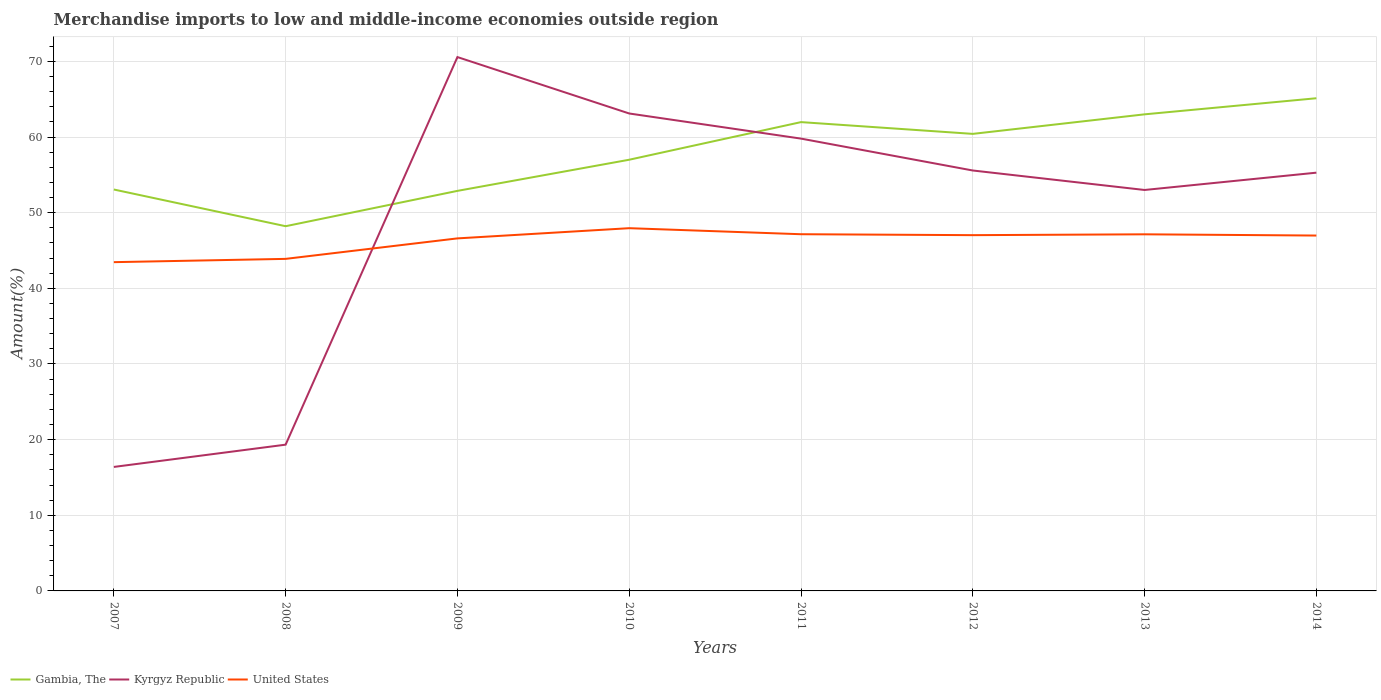How many different coloured lines are there?
Provide a succinct answer. 3. Across all years, what is the maximum percentage of amount earned from merchandise imports in Gambia, The?
Give a very brief answer. 48.21. In which year was the percentage of amount earned from merchandise imports in Gambia, The maximum?
Give a very brief answer. 2008. What is the total percentage of amount earned from merchandise imports in United States in the graph?
Give a very brief answer. -4.49. What is the difference between the highest and the second highest percentage of amount earned from merchandise imports in Gambia, The?
Your answer should be compact. 16.92. What is the difference between the highest and the lowest percentage of amount earned from merchandise imports in Kyrgyz Republic?
Offer a terse response. 6. How many years are there in the graph?
Offer a very short reply. 8. Are the values on the major ticks of Y-axis written in scientific E-notation?
Keep it short and to the point. No. Does the graph contain grids?
Provide a succinct answer. Yes. Where does the legend appear in the graph?
Offer a very short reply. Bottom left. How many legend labels are there?
Ensure brevity in your answer.  3. How are the legend labels stacked?
Provide a short and direct response. Horizontal. What is the title of the graph?
Ensure brevity in your answer.  Merchandise imports to low and middle-income economies outside region. Does "Trinidad and Tobago" appear as one of the legend labels in the graph?
Your answer should be very brief. No. What is the label or title of the Y-axis?
Provide a short and direct response. Amount(%). What is the Amount(%) in Gambia, The in 2007?
Provide a succinct answer. 53.06. What is the Amount(%) in Kyrgyz Republic in 2007?
Your response must be concise. 16.39. What is the Amount(%) of United States in 2007?
Offer a very short reply. 43.46. What is the Amount(%) in Gambia, The in 2008?
Your answer should be very brief. 48.21. What is the Amount(%) in Kyrgyz Republic in 2008?
Ensure brevity in your answer.  19.33. What is the Amount(%) of United States in 2008?
Ensure brevity in your answer.  43.89. What is the Amount(%) in Gambia, The in 2009?
Your answer should be very brief. 52.88. What is the Amount(%) of Kyrgyz Republic in 2009?
Provide a short and direct response. 70.57. What is the Amount(%) in United States in 2009?
Your answer should be compact. 46.6. What is the Amount(%) in Gambia, The in 2010?
Provide a short and direct response. 57. What is the Amount(%) in Kyrgyz Republic in 2010?
Give a very brief answer. 63.11. What is the Amount(%) in United States in 2010?
Make the answer very short. 47.95. What is the Amount(%) of Gambia, The in 2011?
Provide a succinct answer. 61.97. What is the Amount(%) in Kyrgyz Republic in 2011?
Give a very brief answer. 59.79. What is the Amount(%) in United States in 2011?
Ensure brevity in your answer.  47.15. What is the Amount(%) of Gambia, The in 2012?
Your response must be concise. 60.42. What is the Amount(%) in Kyrgyz Republic in 2012?
Keep it short and to the point. 55.58. What is the Amount(%) in United States in 2012?
Your response must be concise. 47.03. What is the Amount(%) of Gambia, The in 2013?
Provide a succinct answer. 63. What is the Amount(%) in Kyrgyz Republic in 2013?
Make the answer very short. 53. What is the Amount(%) in United States in 2013?
Give a very brief answer. 47.14. What is the Amount(%) of Gambia, The in 2014?
Make the answer very short. 65.13. What is the Amount(%) in Kyrgyz Republic in 2014?
Keep it short and to the point. 55.29. What is the Amount(%) in United States in 2014?
Your response must be concise. 46.98. Across all years, what is the maximum Amount(%) of Gambia, The?
Offer a terse response. 65.13. Across all years, what is the maximum Amount(%) of Kyrgyz Republic?
Give a very brief answer. 70.57. Across all years, what is the maximum Amount(%) in United States?
Offer a very short reply. 47.95. Across all years, what is the minimum Amount(%) in Gambia, The?
Offer a very short reply. 48.21. Across all years, what is the minimum Amount(%) in Kyrgyz Republic?
Keep it short and to the point. 16.39. Across all years, what is the minimum Amount(%) of United States?
Keep it short and to the point. 43.46. What is the total Amount(%) of Gambia, The in the graph?
Your response must be concise. 461.68. What is the total Amount(%) in Kyrgyz Republic in the graph?
Your answer should be compact. 393.07. What is the total Amount(%) in United States in the graph?
Your response must be concise. 370.21. What is the difference between the Amount(%) in Gambia, The in 2007 and that in 2008?
Your answer should be compact. 4.85. What is the difference between the Amount(%) of Kyrgyz Republic in 2007 and that in 2008?
Provide a succinct answer. -2.94. What is the difference between the Amount(%) of United States in 2007 and that in 2008?
Offer a very short reply. -0.43. What is the difference between the Amount(%) of Gambia, The in 2007 and that in 2009?
Give a very brief answer. 0.18. What is the difference between the Amount(%) in Kyrgyz Republic in 2007 and that in 2009?
Your response must be concise. -54.18. What is the difference between the Amount(%) in United States in 2007 and that in 2009?
Ensure brevity in your answer.  -3.14. What is the difference between the Amount(%) in Gambia, The in 2007 and that in 2010?
Your answer should be very brief. -3.94. What is the difference between the Amount(%) of Kyrgyz Republic in 2007 and that in 2010?
Provide a succinct answer. -46.72. What is the difference between the Amount(%) of United States in 2007 and that in 2010?
Offer a very short reply. -4.49. What is the difference between the Amount(%) in Gambia, The in 2007 and that in 2011?
Provide a short and direct response. -8.91. What is the difference between the Amount(%) of Kyrgyz Republic in 2007 and that in 2011?
Provide a short and direct response. -43.4. What is the difference between the Amount(%) of United States in 2007 and that in 2011?
Give a very brief answer. -3.69. What is the difference between the Amount(%) of Gambia, The in 2007 and that in 2012?
Make the answer very short. -7.35. What is the difference between the Amount(%) of Kyrgyz Republic in 2007 and that in 2012?
Provide a succinct answer. -39.19. What is the difference between the Amount(%) of United States in 2007 and that in 2012?
Your answer should be very brief. -3.57. What is the difference between the Amount(%) in Gambia, The in 2007 and that in 2013?
Your answer should be compact. -9.94. What is the difference between the Amount(%) in Kyrgyz Republic in 2007 and that in 2013?
Keep it short and to the point. -36.61. What is the difference between the Amount(%) of United States in 2007 and that in 2013?
Provide a succinct answer. -3.68. What is the difference between the Amount(%) of Gambia, The in 2007 and that in 2014?
Provide a short and direct response. -12.06. What is the difference between the Amount(%) in Kyrgyz Republic in 2007 and that in 2014?
Make the answer very short. -38.9. What is the difference between the Amount(%) in United States in 2007 and that in 2014?
Ensure brevity in your answer.  -3.52. What is the difference between the Amount(%) of Gambia, The in 2008 and that in 2009?
Provide a succinct answer. -4.67. What is the difference between the Amount(%) in Kyrgyz Republic in 2008 and that in 2009?
Make the answer very short. -51.24. What is the difference between the Amount(%) in United States in 2008 and that in 2009?
Your response must be concise. -2.71. What is the difference between the Amount(%) in Gambia, The in 2008 and that in 2010?
Give a very brief answer. -8.79. What is the difference between the Amount(%) in Kyrgyz Republic in 2008 and that in 2010?
Make the answer very short. -43.78. What is the difference between the Amount(%) in United States in 2008 and that in 2010?
Provide a succinct answer. -4.06. What is the difference between the Amount(%) in Gambia, The in 2008 and that in 2011?
Offer a terse response. -13.76. What is the difference between the Amount(%) in Kyrgyz Republic in 2008 and that in 2011?
Keep it short and to the point. -40.46. What is the difference between the Amount(%) in United States in 2008 and that in 2011?
Provide a succinct answer. -3.26. What is the difference between the Amount(%) of Gambia, The in 2008 and that in 2012?
Your response must be concise. -12.21. What is the difference between the Amount(%) of Kyrgyz Republic in 2008 and that in 2012?
Your answer should be compact. -36.24. What is the difference between the Amount(%) in United States in 2008 and that in 2012?
Give a very brief answer. -3.14. What is the difference between the Amount(%) in Gambia, The in 2008 and that in 2013?
Keep it short and to the point. -14.79. What is the difference between the Amount(%) of Kyrgyz Republic in 2008 and that in 2013?
Ensure brevity in your answer.  -33.67. What is the difference between the Amount(%) of United States in 2008 and that in 2013?
Your response must be concise. -3.25. What is the difference between the Amount(%) of Gambia, The in 2008 and that in 2014?
Make the answer very short. -16.92. What is the difference between the Amount(%) in Kyrgyz Republic in 2008 and that in 2014?
Give a very brief answer. -35.95. What is the difference between the Amount(%) in United States in 2008 and that in 2014?
Your response must be concise. -3.08. What is the difference between the Amount(%) of Gambia, The in 2009 and that in 2010?
Your answer should be very brief. -4.12. What is the difference between the Amount(%) of Kyrgyz Republic in 2009 and that in 2010?
Your response must be concise. 7.46. What is the difference between the Amount(%) of United States in 2009 and that in 2010?
Your response must be concise. -1.35. What is the difference between the Amount(%) of Gambia, The in 2009 and that in 2011?
Make the answer very short. -9.09. What is the difference between the Amount(%) in Kyrgyz Republic in 2009 and that in 2011?
Your answer should be compact. 10.78. What is the difference between the Amount(%) of United States in 2009 and that in 2011?
Ensure brevity in your answer.  -0.55. What is the difference between the Amount(%) in Gambia, The in 2009 and that in 2012?
Keep it short and to the point. -7.54. What is the difference between the Amount(%) in Kyrgyz Republic in 2009 and that in 2012?
Your answer should be very brief. 14.99. What is the difference between the Amount(%) of United States in 2009 and that in 2012?
Your answer should be very brief. -0.43. What is the difference between the Amount(%) of Gambia, The in 2009 and that in 2013?
Your answer should be compact. -10.12. What is the difference between the Amount(%) of Kyrgyz Republic in 2009 and that in 2013?
Give a very brief answer. 17.57. What is the difference between the Amount(%) of United States in 2009 and that in 2013?
Provide a short and direct response. -0.54. What is the difference between the Amount(%) of Gambia, The in 2009 and that in 2014?
Provide a short and direct response. -12.25. What is the difference between the Amount(%) of Kyrgyz Republic in 2009 and that in 2014?
Your answer should be compact. 15.28. What is the difference between the Amount(%) of United States in 2009 and that in 2014?
Provide a short and direct response. -0.38. What is the difference between the Amount(%) in Gambia, The in 2010 and that in 2011?
Offer a terse response. -4.97. What is the difference between the Amount(%) in Kyrgyz Republic in 2010 and that in 2011?
Provide a short and direct response. 3.32. What is the difference between the Amount(%) in United States in 2010 and that in 2011?
Provide a short and direct response. 0.8. What is the difference between the Amount(%) of Gambia, The in 2010 and that in 2012?
Make the answer very short. -3.42. What is the difference between the Amount(%) in Kyrgyz Republic in 2010 and that in 2012?
Offer a terse response. 7.54. What is the difference between the Amount(%) in United States in 2010 and that in 2012?
Make the answer very short. 0.92. What is the difference between the Amount(%) of Gambia, The in 2010 and that in 2013?
Ensure brevity in your answer.  -6. What is the difference between the Amount(%) in Kyrgyz Republic in 2010 and that in 2013?
Offer a very short reply. 10.11. What is the difference between the Amount(%) of United States in 2010 and that in 2013?
Your response must be concise. 0.81. What is the difference between the Amount(%) of Gambia, The in 2010 and that in 2014?
Offer a terse response. -8.13. What is the difference between the Amount(%) in Kyrgyz Republic in 2010 and that in 2014?
Make the answer very short. 7.82. What is the difference between the Amount(%) of United States in 2010 and that in 2014?
Make the answer very short. 0.97. What is the difference between the Amount(%) in Gambia, The in 2011 and that in 2012?
Provide a succinct answer. 1.55. What is the difference between the Amount(%) in Kyrgyz Republic in 2011 and that in 2012?
Make the answer very short. 4.21. What is the difference between the Amount(%) of United States in 2011 and that in 2012?
Give a very brief answer. 0.12. What is the difference between the Amount(%) in Gambia, The in 2011 and that in 2013?
Offer a terse response. -1.03. What is the difference between the Amount(%) of Kyrgyz Republic in 2011 and that in 2013?
Your answer should be very brief. 6.79. What is the difference between the Amount(%) in United States in 2011 and that in 2013?
Provide a short and direct response. 0.01. What is the difference between the Amount(%) of Gambia, The in 2011 and that in 2014?
Your answer should be compact. -3.16. What is the difference between the Amount(%) of Kyrgyz Republic in 2011 and that in 2014?
Provide a succinct answer. 4.5. What is the difference between the Amount(%) in United States in 2011 and that in 2014?
Keep it short and to the point. 0.17. What is the difference between the Amount(%) in Gambia, The in 2012 and that in 2013?
Provide a succinct answer. -2.58. What is the difference between the Amount(%) of Kyrgyz Republic in 2012 and that in 2013?
Offer a terse response. 2.58. What is the difference between the Amount(%) of United States in 2012 and that in 2013?
Provide a succinct answer. -0.11. What is the difference between the Amount(%) in Gambia, The in 2012 and that in 2014?
Provide a succinct answer. -4.71. What is the difference between the Amount(%) in Kyrgyz Republic in 2012 and that in 2014?
Make the answer very short. 0.29. What is the difference between the Amount(%) of United States in 2012 and that in 2014?
Make the answer very short. 0.05. What is the difference between the Amount(%) in Gambia, The in 2013 and that in 2014?
Provide a short and direct response. -2.13. What is the difference between the Amount(%) of Kyrgyz Republic in 2013 and that in 2014?
Your answer should be very brief. -2.29. What is the difference between the Amount(%) in United States in 2013 and that in 2014?
Offer a very short reply. 0.16. What is the difference between the Amount(%) of Gambia, The in 2007 and the Amount(%) of Kyrgyz Republic in 2008?
Provide a short and direct response. 33.73. What is the difference between the Amount(%) of Gambia, The in 2007 and the Amount(%) of United States in 2008?
Give a very brief answer. 9.17. What is the difference between the Amount(%) in Kyrgyz Republic in 2007 and the Amount(%) in United States in 2008?
Offer a terse response. -27.5. What is the difference between the Amount(%) of Gambia, The in 2007 and the Amount(%) of Kyrgyz Republic in 2009?
Give a very brief answer. -17.51. What is the difference between the Amount(%) in Gambia, The in 2007 and the Amount(%) in United States in 2009?
Your answer should be compact. 6.46. What is the difference between the Amount(%) of Kyrgyz Republic in 2007 and the Amount(%) of United States in 2009?
Your answer should be very brief. -30.21. What is the difference between the Amount(%) in Gambia, The in 2007 and the Amount(%) in Kyrgyz Republic in 2010?
Offer a terse response. -10.05. What is the difference between the Amount(%) in Gambia, The in 2007 and the Amount(%) in United States in 2010?
Provide a short and direct response. 5.11. What is the difference between the Amount(%) of Kyrgyz Republic in 2007 and the Amount(%) of United States in 2010?
Give a very brief answer. -31.56. What is the difference between the Amount(%) of Gambia, The in 2007 and the Amount(%) of Kyrgyz Republic in 2011?
Ensure brevity in your answer.  -6.73. What is the difference between the Amount(%) in Gambia, The in 2007 and the Amount(%) in United States in 2011?
Give a very brief answer. 5.91. What is the difference between the Amount(%) of Kyrgyz Republic in 2007 and the Amount(%) of United States in 2011?
Keep it short and to the point. -30.76. What is the difference between the Amount(%) in Gambia, The in 2007 and the Amount(%) in Kyrgyz Republic in 2012?
Your response must be concise. -2.51. What is the difference between the Amount(%) of Gambia, The in 2007 and the Amount(%) of United States in 2012?
Offer a very short reply. 6.03. What is the difference between the Amount(%) of Kyrgyz Republic in 2007 and the Amount(%) of United States in 2012?
Provide a succinct answer. -30.64. What is the difference between the Amount(%) of Gambia, The in 2007 and the Amount(%) of Kyrgyz Republic in 2013?
Provide a succinct answer. 0.06. What is the difference between the Amount(%) of Gambia, The in 2007 and the Amount(%) of United States in 2013?
Your answer should be compact. 5.92. What is the difference between the Amount(%) in Kyrgyz Republic in 2007 and the Amount(%) in United States in 2013?
Offer a very short reply. -30.75. What is the difference between the Amount(%) in Gambia, The in 2007 and the Amount(%) in Kyrgyz Republic in 2014?
Your answer should be very brief. -2.22. What is the difference between the Amount(%) of Gambia, The in 2007 and the Amount(%) of United States in 2014?
Offer a very short reply. 6.09. What is the difference between the Amount(%) in Kyrgyz Republic in 2007 and the Amount(%) in United States in 2014?
Ensure brevity in your answer.  -30.59. What is the difference between the Amount(%) in Gambia, The in 2008 and the Amount(%) in Kyrgyz Republic in 2009?
Your answer should be compact. -22.36. What is the difference between the Amount(%) in Gambia, The in 2008 and the Amount(%) in United States in 2009?
Provide a short and direct response. 1.61. What is the difference between the Amount(%) in Kyrgyz Republic in 2008 and the Amount(%) in United States in 2009?
Your answer should be compact. -27.27. What is the difference between the Amount(%) of Gambia, The in 2008 and the Amount(%) of Kyrgyz Republic in 2010?
Provide a succinct answer. -14.9. What is the difference between the Amount(%) in Gambia, The in 2008 and the Amount(%) in United States in 2010?
Make the answer very short. 0.26. What is the difference between the Amount(%) in Kyrgyz Republic in 2008 and the Amount(%) in United States in 2010?
Your answer should be compact. -28.62. What is the difference between the Amount(%) in Gambia, The in 2008 and the Amount(%) in Kyrgyz Republic in 2011?
Give a very brief answer. -11.58. What is the difference between the Amount(%) of Gambia, The in 2008 and the Amount(%) of United States in 2011?
Your answer should be compact. 1.06. What is the difference between the Amount(%) of Kyrgyz Republic in 2008 and the Amount(%) of United States in 2011?
Offer a very short reply. -27.82. What is the difference between the Amount(%) of Gambia, The in 2008 and the Amount(%) of Kyrgyz Republic in 2012?
Your answer should be compact. -7.37. What is the difference between the Amount(%) of Gambia, The in 2008 and the Amount(%) of United States in 2012?
Your response must be concise. 1.18. What is the difference between the Amount(%) of Kyrgyz Republic in 2008 and the Amount(%) of United States in 2012?
Offer a very short reply. -27.7. What is the difference between the Amount(%) in Gambia, The in 2008 and the Amount(%) in Kyrgyz Republic in 2013?
Your answer should be very brief. -4.79. What is the difference between the Amount(%) of Gambia, The in 2008 and the Amount(%) of United States in 2013?
Give a very brief answer. 1.07. What is the difference between the Amount(%) of Kyrgyz Republic in 2008 and the Amount(%) of United States in 2013?
Provide a short and direct response. -27.81. What is the difference between the Amount(%) of Gambia, The in 2008 and the Amount(%) of Kyrgyz Republic in 2014?
Your response must be concise. -7.08. What is the difference between the Amount(%) in Gambia, The in 2008 and the Amount(%) in United States in 2014?
Your answer should be very brief. 1.23. What is the difference between the Amount(%) in Kyrgyz Republic in 2008 and the Amount(%) in United States in 2014?
Your response must be concise. -27.64. What is the difference between the Amount(%) in Gambia, The in 2009 and the Amount(%) in Kyrgyz Republic in 2010?
Provide a short and direct response. -10.23. What is the difference between the Amount(%) of Gambia, The in 2009 and the Amount(%) of United States in 2010?
Provide a succinct answer. 4.93. What is the difference between the Amount(%) in Kyrgyz Republic in 2009 and the Amount(%) in United States in 2010?
Your answer should be very brief. 22.62. What is the difference between the Amount(%) in Gambia, The in 2009 and the Amount(%) in Kyrgyz Republic in 2011?
Give a very brief answer. -6.91. What is the difference between the Amount(%) of Gambia, The in 2009 and the Amount(%) of United States in 2011?
Your answer should be compact. 5.73. What is the difference between the Amount(%) in Kyrgyz Republic in 2009 and the Amount(%) in United States in 2011?
Keep it short and to the point. 23.42. What is the difference between the Amount(%) in Gambia, The in 2009 and the Amount(%) in Kyrgyz Republic in 2012?
Keep it short and to the point. -2.69. What is the difference between the Amount(%) in Gambia, The in 2009 and the Amount(%) in United States in 2012?
Make the answer very short. 5.85. What is the difference between the Amount(%) of Kyrgyz Republic in 2009 and the Amount(%) of United States in 2012?
Keep it short and to the point. 23.54. What is the difference between the Amount(%) of Gambia, The in 2009 and the Amount(%) of Kyrgyz Republic in 2013?
Keep it short and to the point. -0.12. What is the difference between the Amount(%) in Gambia, The in 2009 and the Amount(%) in United States in 2013?
Offer a very short reply. 5.74. What is the difference between the Amount(%) of Kyrgyz Republic in 2009 and the Amount(%) of United States in 2013?
Give a very brief answer. 23.43. What is the difference between the Amount(%) in Gambia, The in 2009 and the Amount(%) in Kyrgyz Republic in 2014?
Provide a short and direct response. -2.41. What is the difference between the Amount(%) of Gambia, The in 2009 and the Amount(%) of United States in 2014?
Offer a very short reply. 5.9. What is the difference between the Amount(%) in Kyrgyz Republic in 2009 and the Amount(%) in United States in 2014?
Your answer should be very brief. 23.59. What is the difference between the Amount(%) of Gambia, The in 2010 and the Amount(%) of Kyrgyz Republic in 2011?
Your response must be concise. -2.79. What is the difference between the Amount(%) in Gambia, The in 2010 and the Amount(%) in United States in 2011?
Give a very brief answer. 9.85. What is the difference between the Amount(%) in Kyrgyz Republic in 2010 and the Amount(%) in United States in 2011?
Offer a terse response. 15.96. What is the difference between the Amount(%) of Gambia, The in 2010 and the Amount(%) of Kyrgyz Republic in 2012?
Offer a terse response. 1.42. What is the difference between the Amount(%) in Gambia, The in 2010 and the Amount(%) in United States in 2012?
Your answer should be compact. 9.97. What is the difference between the Amount(%) in Kyrgyz Republic in 2010 and the Amount(%) in United States in 2012?
Offer a very short reply. 16.08. What is the difference between the Amount(%) of Gambia, The in 2010 and the Amount(%) of Kyrgyz Republic in 2013?
Provide a succinct answer. 4. What is the difference between the Amount(%) in Gambia, The in 2010 and the Amount(%) in United States in 2013?
Offer a terse response. 9.86. What is the difference between the Amount(%) in Kyrgyz Republic in 2010 and the Amount(%) in United States in 2013?
Your answer should be compact. 15.97. What is the difference between the Amount(%) in Gambia, The in 2010 and the Amount(%) in Kyrgyz Republic in 2014?
Your response must be concise. 1.71. What is the difference between the Amount(%) of Gambia, The in 2010 and the Amount(%) of United States in 2014?
Provide a succinct answer. 10.02. What is the difference between the Amount(%) in Kyrgyz Republic in 2010 and the Amount(%) in United States in 2014?
Provide a succinct answer. 16.13. What is the difference between the Amount(%) of Gambia, The in 2011 and the Amount(%) of Kyrgyz Republic in 2012?
Offer a very short reply. 6.4. What is the difference between the Amount(%) in Gambia, The in 2011 and the Amount(%) in United States in 2012?
Give a very brief answer. 14.94. What is the difference between the Amount(%) in Kyrgyz Republic in 2011 and the Amount(%) in United States in 2012?
Offer a very short reply. 12.76. What is the difference between the Amount(%) of Gambia, The in 2011 and the Amount(%) of Kyrgyz Republic in 2013?
Give a very brief answer. 8.97. What is the difference between the Amount(%) in Gambia, The in 2011 and the Amount(%) in United States in 2013?
Provide a short and direct response. 14.83. What is the difference between the Amount(%) in Kyrgyz Republic in 2011 and the Amount(%) in United States in 2013?
Provide a short and direct response. 12.65. What is the difference between the Amount(%) in Gambia, The in 2011 and the Amount(%) in Kyrgyz Republic in 2014?
Your answer should be very brief. 6.68. What is the difference between the Amount(%) in Gambia, The in 2011 and the Amount(%) in United States in 2014?
Make the answer very short. 14.99. What is the difference between the Amount(%) of Kyrgyz Republic in 2011 and the Amount(%) of United States in 2014?
Ensure brevity in your answer.  12.81. What is the difference between the Amount(%) in Gambia, The in 2012 and the Amount(%) in Kyrgyz Republic in 2013?
Keep it short and to the point. 7.42. What is the difference between the Amount(%) in Gambia, The in 2012 and the Amount(%) in United States in 2013?
Offer a very short reply. 13.28. What is the difference between the Amount(%) of Kyrgyz Republic in 2012 and the Amount(%) of United States in 2013?
Your answer should be compact. 8.44. What is the difference between the Amount(%) of Gambia, The in 2012 and the Amount(%) of Kyrgyz Republic in 2014?
Ensure brevity in your answer.  5.13. What is the difference between the Amount(%) in Gambia, The in 2012 and the Amount(%) in United States in 2014?
Your answer should be compact. 13.44. What is the difference between the Amount(%) of Kyrgyz Republic in 2012 and the Amount(%) of United States in 2014?
Keep it short and to the point. 8.6. What is the difference between the Amount(%) of Gambia, The in 2013 and the Amount(%) of Kyrgyz Republic in 2014?
Ensure brevity in your answer.  7.71. What is the difference between the Amount(%) of Gambia, The in 2013 and the Amount(%) of United States in 2014?
Offer a very short reply. 16.02. What is the difference between the Amount(%) of Kyrgyz Republic in 2013 and the Amount(%) of United States in 2014?
Provide a succinct answer. 6.02. What is the average Amount(%) in Gambia, The per year?
Provide a short and direct response. 57.71. What is the average Amount(%) in Kyrgyz Republic per year?
Offer a terse response. 49.13. What is the average Amount(%) in United States per year?
Provide a succinct answer. 46.28. In the year 2007, what is the difference between the Amount(%) in Gambia, The and Amount(%) in Kyrgyz Republic?
Ensure brevity in your answer.  36.67. In the year 2007, what is the difference between the Amount(%) in Gambia, The and Amount(%) in United States?
Your answer should be very brief. 9.6. In the year 2007, what is the difference between the Amount(%) of Kyrgyz Republic and Amount(%) of United States?
Provide a succinct answer. -27.07. In the year 2008, what is the difference between the Amount(%) in Gambia, The and Amount(%) in Kyrgyz Republic?
Make the answer very short. 28.88. In the year 2008, what is the difference between the Amount(%) of Gambia, The and Amount(%) of United States?
Your response must be concise. 4.32. In the year 2008, what is the difference between the Amount(%) of Kyrgyz Republic and Amount(%) of United States?
Keep it short and to the point. -24.56. In the year 2009, what is the difference between the Amount(%) of Gambia, The and Amount(%) of Kyrgyz Republic?
Your answer should be compact. -17.69. In the year 2009, what is the difference between the Amount(%) in Gambia, The and Amount(%) in United States?
Offer a terse response. 6.28. In the year 2009, what is the difference between the Amount(%) of Kyrgyz Republic and Amount(%) of United States?
Your response must be concise. 23.97. In the year 2010, what is the difference between the Amount(%) of Gambia, The and Amount(%) of Kyrgyz Republic?
Keep it short and to the point. -6.11. In the year 2010, what is the difference between the Amount(%) of Gambia, The and Amount(%) of United States?
Your answer should be compact. 9.05. In the year 2010, what is the difference between the Amount(%) in Kyrgyz Republic and Amount(%) in United States?
Your answer should be very brief. 15.16. In the year 2011, what is the difference between the Amount(%) in Gambia, The and Amount(%) in Kyrgyz Republic?
Keep it short and to the point. 2.18. In the year 2011, what is the difference between the Amount(%) of Gambia, The and Amount(%) of United States?
Your answer should be very brief. 14.82. In the year 2011, what is the difference between the Amount(%) in Kyrgyz Republic and Amount(%) in United States?
Give a very brief answer. 12.64. In the year 2012, what is the difference between the Amount(%) in Gambia, The and Amount(%) in Kyrgyz Republic?
Make the answer very short. 4.84. In the year 2012, what is the difference between the Amount(%) in Gambia, The and Amount(%) in United States?
Your response must be concise. 13.39. In the year 2012, what is the difference between the Amount(%) in Kyrgyz Republic and Amount(%) in United States?
Give a very brief answer. 8.55. In the year 2013, what is the difference between the Amount(%) of Gambia, The and Amount(%) of Kyrgyz Republic?
Provide a short and direct response. 10. In the year 2013, what is the difference between the Amount(%) in Gambia, The and Amount(%) in United States?
Ensure brevity in your answer.  15.86. In the year 2013, what is the difference between the Amount(%) of Kyrgyz Republic and Amount(%) of United States?
Your answer should be very brief. 5.86. In the year 2014, what is the difference between the Amount(%) in Gambia, The and Amount(%) in Kyrgyz Republic?
Provide a short and direct response. 9.84. In the year 2014, what is the difference between the Amount(%) of Gambia, The and Amount(%) of United States?
Your answer should be very brief. 18.15. In the year 2014, what is the difference between the Amount(%) in Kyrgyz Republic and Amount(%) in United States?
Ensure brevity in your answer.  8.31. What is the ratio of the Amount(%) in Gambia, The in 2007 to that in 2008?
Keep it short and to the point. 1.1. What is the ratio of the Amount(%) of Kyrgyz Republic in 2007 to that in 2008?
Give a very brief answer. 0.85. What is the ratio of the Amount(%) of United States in 2007 to that in 2008?
Provide a succinct answer. 0.99. What is the ratio of the Amount(%) in Gambia, The in 2007 to that in 2009?
Make the answer very short. 1. What is the ratio of the Amount(%) in Kyrgyz Republic in 2007 to that in 2009?
Ensure brevity in your answer.  0.23. What is the ratio of the Amount(%) in United States in 2007 to that in 2009?
Your response must be concise. 0.93. What is the ratio of the Amount(%) in Gambia, The in 2007 to that in 2010?
Offer a very short reply. 0.93. What is the ratio of the Amount(%) of Kyrgyz Republic in 2007 to that in 2010?
Your response must be concise. 0.26. What is the ratio of the Amount(%) in United States in 2007 to that in 2010?
Your answer should be compact. 0.91. What is the ratio of the Amount(%) of Gambia, The in 2007 to that in 2011?
Your answer should be very brief. 0.86. What is the ratio of the Amount(%) in Kyrgyz Republic in 2007 to that in 2011?
Your answer should be very brief. 0.27. What is the ratio of the Amount(%) of United States in 2007 to that in 2011?
Make the answer very short. 0.92. What is the ratio of the Amount(%) in Gambia, The in 2007 to that in 2012?
Keep it short and to the point. 0.88. What is the ratio of the Amount(%) of Kyrgyz Republic in 2007 to that in 2012?
Give a very brief answer. 0.29. What is the ratio of the Amount(%) of United States in 2007 to that in 2012?
Ensure brevity in your answer.  0.92. What is the ratio of the Amount(%) in Gambia, The in 2007 to that in 2013?
Your answer should be very brief. 0.84. What is the ratio of the Amount(%) in Kyrgyz Republic in 2007 to that in 2013?
Keep it short and to the point. 0.31. What is the ratio of the Amount(%) of United States in 2007 to that in 2013?
Offer a very short reply. 0.92. What is the ratio of the Amount(%) of Gambia, The in 2007 to that in 2014?
Give a very brief answer. 0.81. What is the ratio of the Amount(%) in Kyrgyz Republic in 2007 to that in 2014?
Offer a terse response. 0.3. What is the ratio of the Amount(%) of United States in 2007 to that in 2014?
Offer a very short reply. 0.93. What is the ratio of the Amount(%) in Gambia, The in 2008 to that in 2009?
Keep it short and to the point. 0.91. What is the ratio of the Amount(%) of Kyrgyz Republic in 2008 to that in 2009?
Your answer should be very brief. 0.27. What is the ratio of the Amount(%) in United States in 2008 to that in 2009?
Your answer should be very brief. 0.94. What is the ratio of the Amount(%) of Gambia, The in 2008 to that in 2010?
Make the answer very short. 0.85. What is the ratio of the Amount(%) of Kyrgyz Republic in 2008 to that in 2010?
Your answer should be very brief. 0.31. What is the ratio of the Amount(%) in United States in 2008 to that in 2010?
Ensure brevity in your answer.  0.92. What is the ratio of the Amount(%) in Gambia, The in 2008 to that in 2011?
Give a very brief answer. 0.78. What is the ratio of the Amount(%) of Kyrgyz Republic in 2008 to that in 2011?
Keep it short and to the point. 0.32. What is the ratio of the Amount(%) in United States in 2008 to that in 2011?
Provide a short and direct response. 0.93. What is the ratio of the Amount(%) of Gambia, The in 2008 to that in 2012?
Offer a terse response. 0.8. What is the ratio of the Amount(%) of Kyrgyz Republic in 2008 to that in 2012?
Offer a terse response. 0.35. What is the ratio of the Amount(%) in Gambia, The in 2008 to that in 2013?
Offer a terse response. 0.77. What is the ratio of the Amount(%) in Kyrgyz Republic in 2008 to that in 2013?
Provide a succinct answer. 0.36. What is the ratio of the Amount(%) of United States in 2008 to that in 2013?
Your answer should be compact. 0.93. What is the ratio of the Amount(%) in Gambia, The in 2008 to that in 2014?
Make the answer very short. 0.74. What is the ratio of the Amount(%) of Kyrgyz Republic in 2008 to that in 2014?
Your answer should be compact. 0.35. What is the ratio of the Amount(%) of United States in 2008 to that in 2014?
Give a very brief answer. 0.93. What is the ratio of the Amount(%) of Gambia, The in 2009 to that in 2010?
Your response must be concise. 0.93. What is the ratio of the Amount(%) in Kyrgyz Republic in 2009 to that in 2010?
Your answer should be compact. 1.12. What is the ratio of the Amount(%) of United States in 2009 to that in 2010?
Offer a terse response. 0.97. What is the ratio of the Amount(%) in Gambia, The in 2009 to that in 2011?
Provide a succinct answer. 0.85. What is the ratio of the Amount(%) in Kyrgyz Republic in 2009 to that in 2011?
Make the answer very short. 1.18. What is the ratio of the Amount(%) in United States in 2009 to that in 2011?
Offer a terse response. 0.99. What is the ratio of the Amount(%) in Gambia, The in 2009 to that in 2012?
Ensure brevity in your answer.  0.88. What is the ratio of the Amount(%) of Kyrgyz Republic in 2009 to that in 2012?
Provide a short and direct response. 1.27. What is the ratio of the Amount(%) of United States in 2009 to that in 2012?
Provide a succinct answer. 0.99. What is the ratio of the Amount(%) of Gambia, The in 2009 to that in 2013?
Your answer should be compact. 0.84. What is the ratio of the Amount(%) in Kyrgyz Republic in 2009 to that in 2013?
Your answer should be very brief. 1.33. What is the ratio of the Amount(%) in United States in 2009 to that in 2013?
Make the answer very short. 0.99. What is the ratio of the Amount(%) in Gambia, The in 2009 to that in 2014?
Provide a succinct answer. 0.81. What is the ratio of the Amount(%) in Kyrgyz Republic in 2009 to that in 2014?
Provide a short and direct response. 1.28. What is the ratio of the Amount(%) of United States in 2009 to that in 2014?
Your answer should be very brief. 0.99. What is the ratio of the Amount(%) in Gambia, The in 2010 to that in 2011?
Provide a succinct answer. 0.92. What is the ratio of the Amount(%) in Kyrgyz Republic in 2010 to that in 2011?
Your response must be concise. 1.06. What is the ratio of the Amount(%) in United States in 2010 to that in 2011?
Offer a very short reply. 1.02. What is the ratio of the Amount(%) in Gambia, The in 2010 to that in 2012?
Make the answer very short. 0.94. What is the ratio of the Amount(%) in Kyrgyz Republic in 2010 to that in 2012?
Make the answer very short. 1.14. What is the ratio of the Amount(%) of United States in 2010 to that in 2012?
Provide a short and direct response. 1.02. What is the ratio of the Amount(%) of Gambia, The in 2010 to that in 2013?
Provide a short and direct response. 0.9. What is the ratio of the Amount(%) of Kyrgyz Republic in 2010 to that in 2013?
Your answer should be very brief. 1.19. What is the ratio of the Amount(%) of United States in 2010 to that in 2013?
Ensure brevity in your answer.  1.02. What is the ratio of the Amount(%) in Gambia, The in 2010 to that in 2014?
Offer a very short reply. 0.88. What is the ratio of the Amount(%) of Kyrgyz Republic in 2010 to that in 2014?
Provide a short and direct response. 1.14. What is the ratio of the Amount(%) in United States in 2010 to that in 2014?
Keep it short and to the point. 1.02. What is the ratio of the Amount(%) of Gambia, The in 2011 to that in 2012?
Your response must be concise. 1.03. What is the ratio of the Amount(%) in Kyrgyz Republic in 2011 to that in 2012?
Your response must be concise. 1.08. What is the ratio of the Amount(%) of United States in 2011 to that in 2012?
Give a very brief answer. 1. What is the ratio of the Amount(%) in Gambia, The in 2011 to that in 2013?
Ensure brevity in your answer.  0.98. What is the ratio of the Amount(%) of Kyrgyz Republic in 2011 to that in 2013?
Offer a very short reply. 1.13. What is the ratio of the Amount(%) of Gambia, The in 2011 to that in 2014?
Offer a very short reply. 0.95. What is the ratio of the Amount(%) of Kyrgyz Republic in 2011 to that in 2014?
Ensure brevity in your answer.  1.08. What is the ratio of the Amount(%) of United States in 2011 to that in 2014?
Keep it short and to the point. 1. What is the ratio of the Amount(%) of Kyrgyz Republic in 2012 to that in 2013?
Provide a succinct answer. 1.05. What is the ratio of the Amount(%) in Gambia, The in 2012 to that in 2014?
Your answer should be compact. 0.93. What is the ratio of the Amount(%) in Gambia, The in 2013 to that in 2014?
Keep it short and to the point. 0.97. What is the ratio of the Amount(%) of Kyrgyz Republic in 2013 to that in 2014?
Ensure brevity in your answer.  0.96. What is the difference between the highest and the second highest Amount(%) of Gambia, The?
Your answer should be compact. 2.13. What is the difference between the highest and the second highest Amount(%) in Kyrgyz Republic?
Offer a terse response. 7.46. What is the difference between the highest and the second highest Amount(%) in United States?
Offer a very short reply. 0.8. What is the difference between the highest and the lowest Amount(%) in Gambia, The?
Make the answer very short. 16.92. What is the difference between the highest and the lowest Amount(%) in Kyrgyz Republic?
Offer a terse response. 54.18. What is the difference between the highest and the lowest Amount(%) in United States?
Provide a succinct answer. 4.49. 